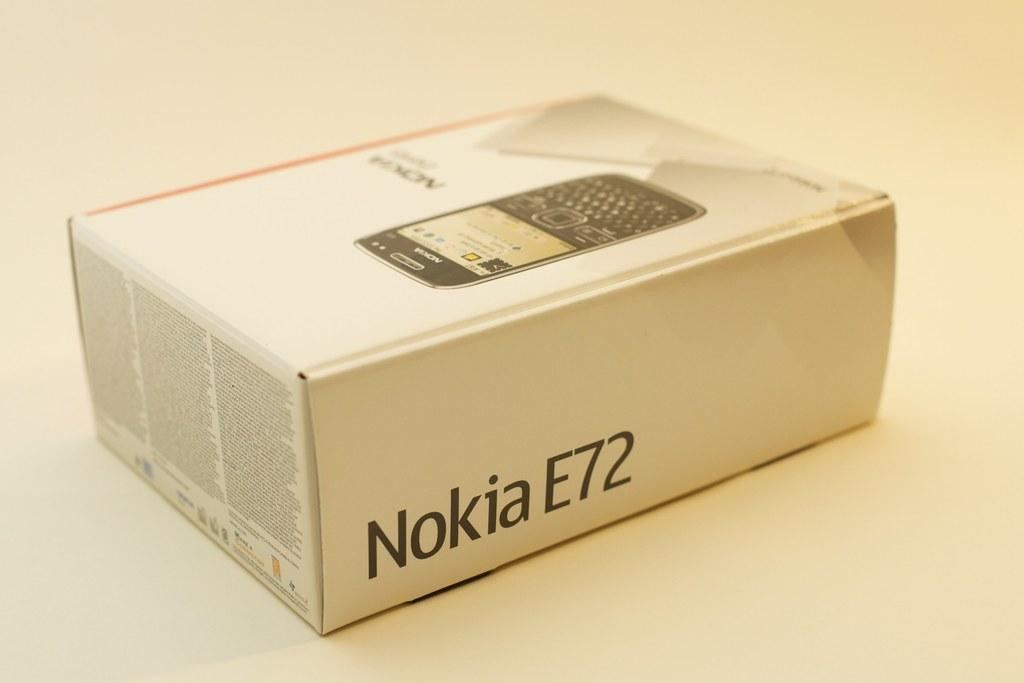<image>
Provide a brief description of the given image. the word Nokia is on the side of a box 